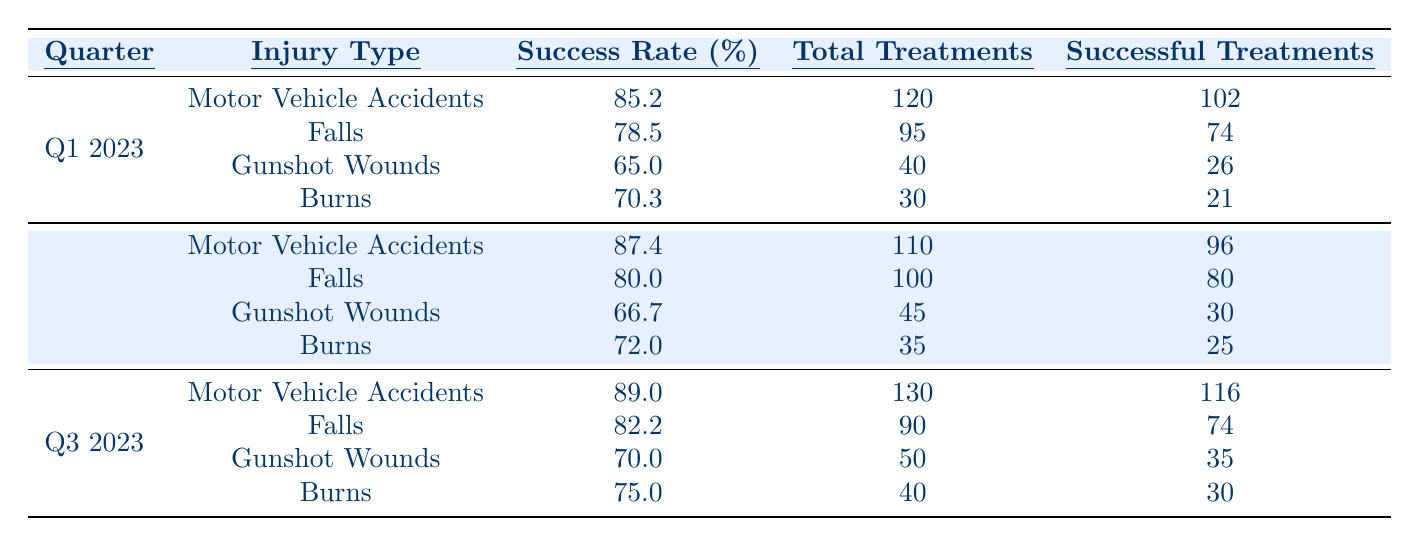What is the success rate for Motor Vehicle Accidents in Q2 2023? The table shows that the success rate for Motor Vehicle Accidents in Q2 2023 is listed under that quarter’s injury type section. Specifically, it states a success rate of 87.4%.
Answer: 87.4% How many total treatments were there for Falls in Q1 2023? The table indicates that for Falls in Q1 2023, the total treatments are specified in that row, which shows a total of 95 treatments.
Answer: 95 Which injury type had the highest success rate in Q3 2023? To find the highest success rate in Q3 2023, we compare the success rates for all injury types listed for that quarter: Motor Vehicle Accidents (89.0%), Falls (82.2%), Gunshot Wounds (70.0%), and Burns (75.0%). The highest is Motor Vehicle Accidents at 89.0%.
Answer: Motor Vehicle Accidents What is the total number of successful treatments for Gunshot Wounds across all quarters? We sum the successful treatments for Gunshot Wounds from each quarter: Q1 (26) + Q2 (30) + Q3 (35). This gives us 26 + 30 + 35 = 91 successful treatments in total.
Answer: 91 Is the success rate for Burns in Q1 2023 higher than in Q2 2023? The success rates for Burns are shown as 70.3% in Q1 2023 and 72.0% in Q2 2023. Since 70.3% is less than 72.0%, the answer to the question is no.
Answer: No What is the average success rate for Falls across all three quarters? To find the average success rate for Falls, we first extract the success rates: Q1 (78.5%), Q2 (80.0%), Q3 (82.2%). Next, we add them: 78.5 + 80.0 + 82.2 = 240.7. We then divide by 3: 240.7 / 3 = 80.23%.
Answer: 80.23% Which quarter saw the lowest success rate for Gunshot Wounds? The success rates for Gunshot Wounds are 65.0% in Q1 2023, 66.7% in Q2 2023, and 70.0% in Q3 2023. The lowest of these rates is in Q1 2023 at 65.0%.
Answer: Q1 2023 How many more total treatments were performed for Motor Vehicle Accidents in Q3 2023 compared to Q2 2023? The total treatments for Motor Vehicle Accidents in Q3 2023 is 130 and in Q2 2023 is 110. Subtracting these two values gives us 130 - 110 = 20 additional treatments in Q3.
Answer: 20 Was the success rate for Burns higher in Q3 2023 than for Gunshot Wounds in the same quarter? In Q3 2023, the success rate for Burns is 75.0% while for Gunshot Wounds it is 70.0%. Since 75.0% is greater than 70.0%, the answer is yes.
Answer: Yes What percentage increase in success rate did Motor Vehicle Accidents see from Q1 2023 to Q3 2023? The success rate for Motor Vehicle Accidents increased from 85.2% in Q1 2023 to 89.0% in Q3 2023. The increase can be calculated as (89.0 - 85.2) / 85.2 * 100 = 4.47%.
Answer: 4.47% 